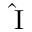Convert formula to latex. <formula><loc_0><loc_0><loc_500><loc_500>{ \hat { I } }</formula> 